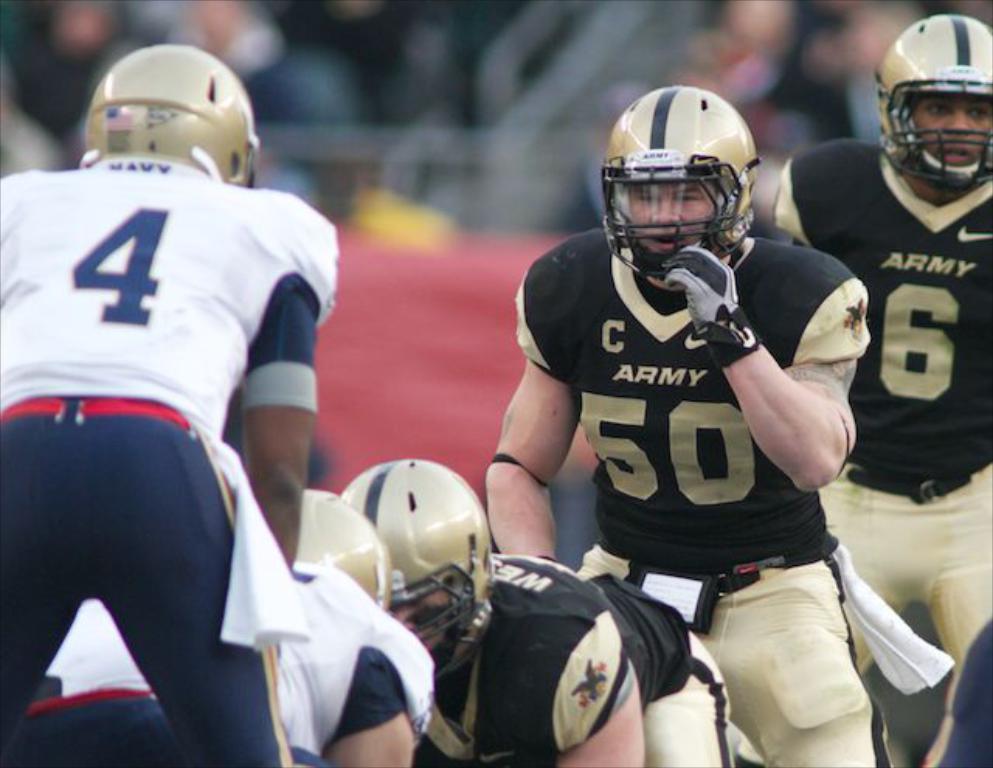Could you give a brief overview of what you see in this image? This picture is taken in the playground. In this image, we can see a group of people wearing helmet. In the background, we can see a black color and red color. 